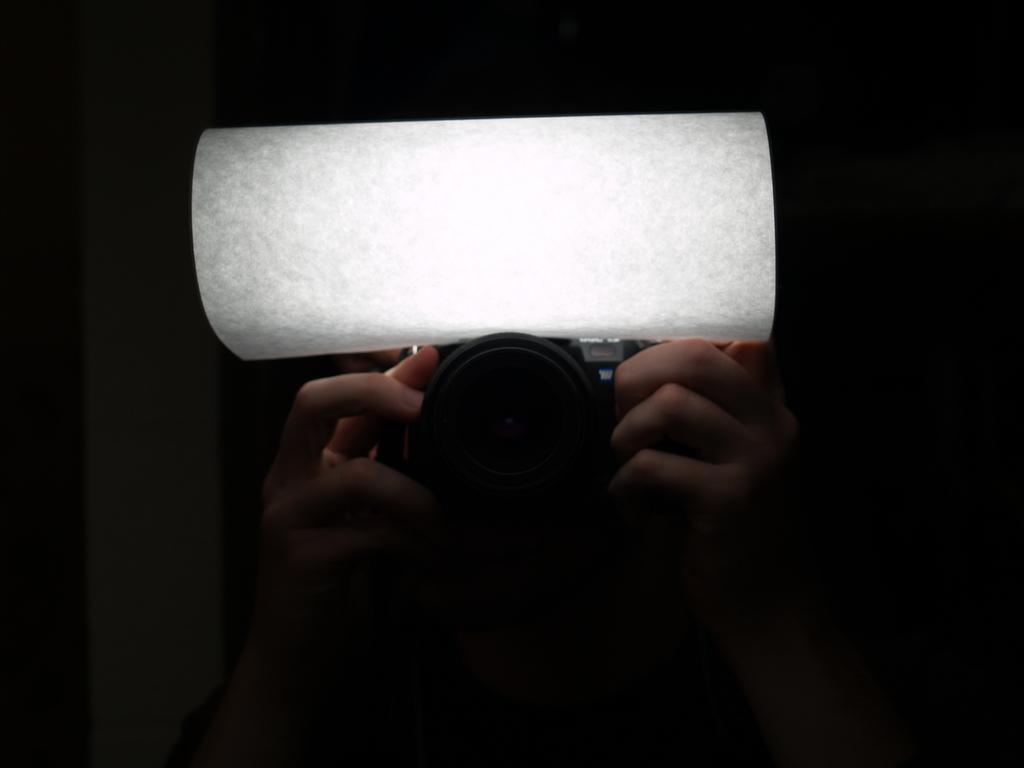Who or what is the main subject in the image? There is a person in the image. What is the person holding in the image? The person is holding a camera. Can you describe the color of any object in the image? There is a white color object in the image. How would you describe the overall lighting or color scheme of the image? The background of the image is dark. What type of lunch is being served to the committee at the dock in the image? There is no mention of a lunch, committee, or dock in the image. The image features a person holding a camera with a dark background and a white object. 